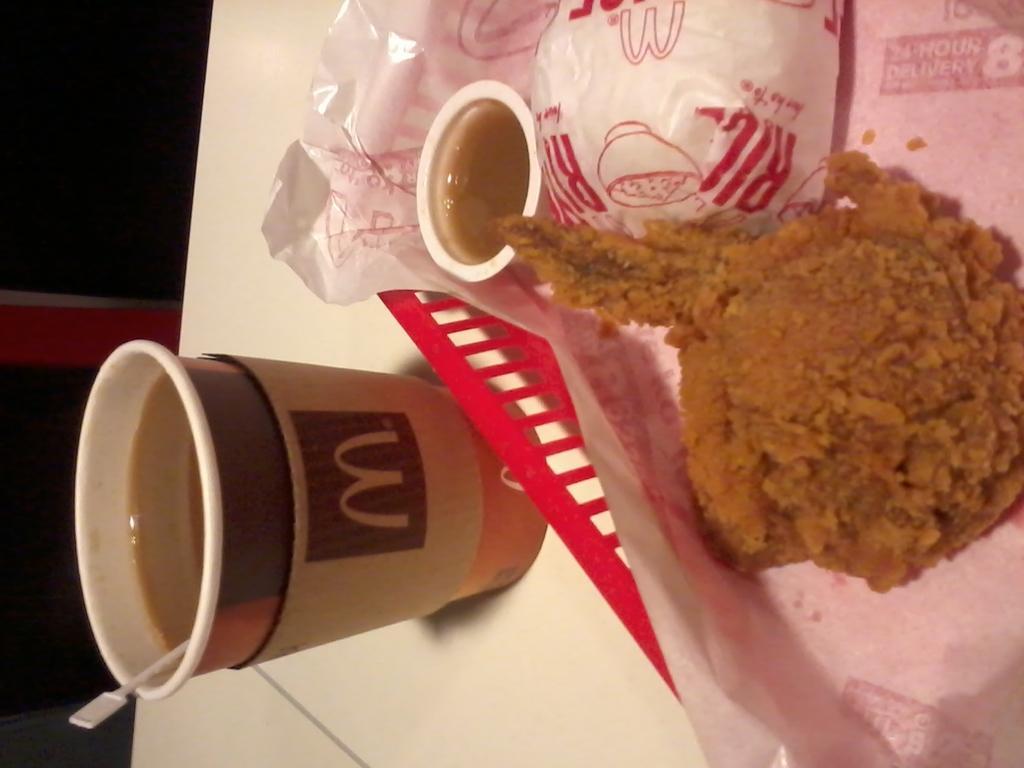How would you summarize this image in a sentence or two? This image consists of chicken and coffee cups. At the bottom, there is a table in white color. 